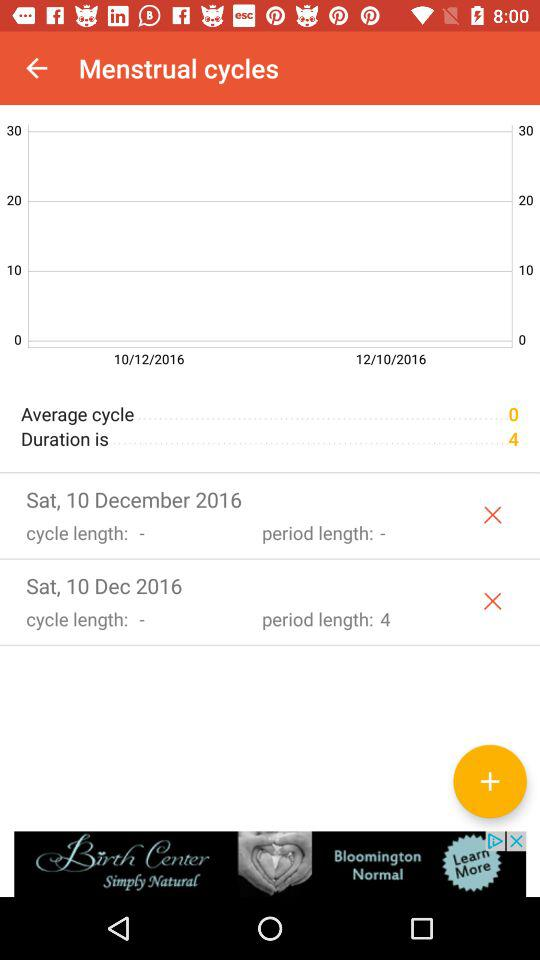What is the selected date? The selected date is Saturday, December 10, 2016. 